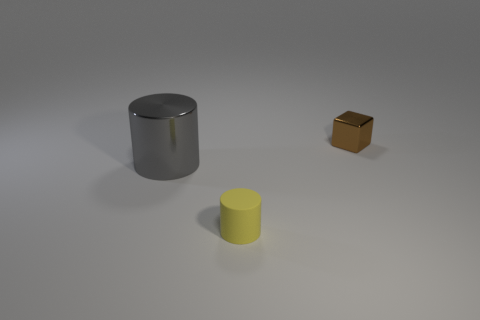Add 2 yellow cylinders. How many objects exist? 5 Subtract all cubes. How many objects are left? 2 Subtract all cylinders. Subtract all tiny yellow cylinders. How many objects are left? 0 Add 2 yellow things. How many yellow things are left? 3 Add 3 tiny objects. How many tiny objects exist? 5 Subtract 0 purple cylinders. How many objects are left? 3 